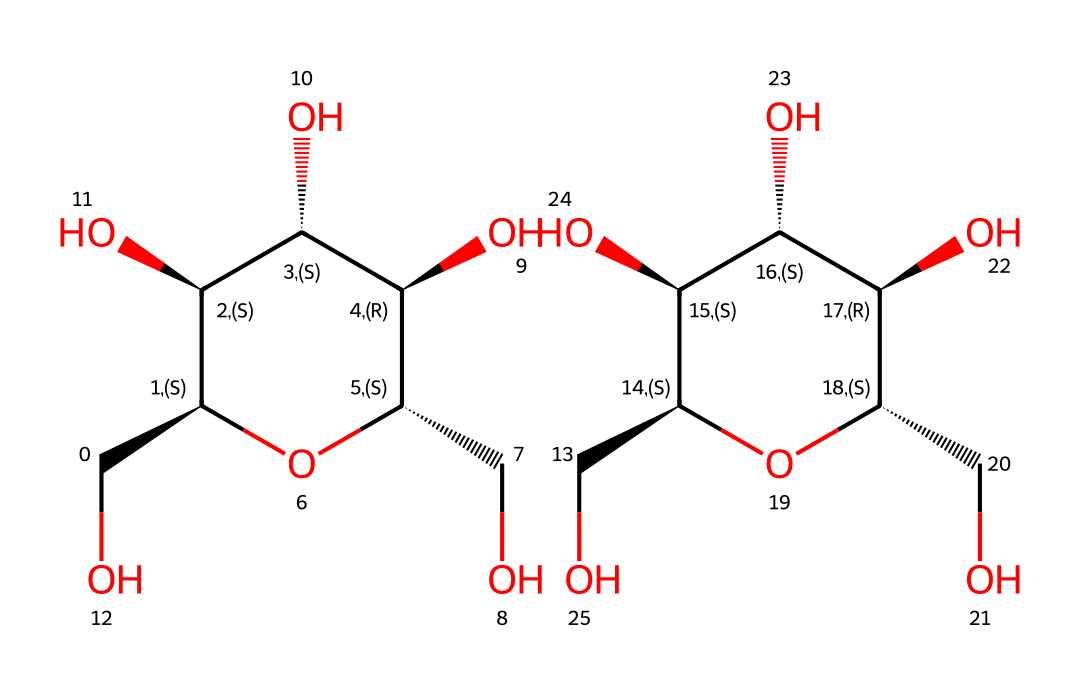What is the molecular formula of this starch molecule? The SMILES representation describes a chemical structure of starch. By analyzing the atoms represented in the structure, we find that the molecular formula is a combination of carbon (C), hydrogen (H), and oxygen (O). Counting the atoms from the two parts of the structure, we deduce the molecular formula as C12H22O11.
Answer: C12H22O11 How many rings are present in this chemical structure? The SMILES notation indicates that there are two cyclic structures (rings) present. Each cycle is formed by the notation that includes the sequence of atoms and the '@' symbols signify chirality in these rings. Hence, there are two ring structures in total.
Answer: 2 What functional groups are evident in this carbohydrate? Observing the structure closely, we see multiple hydroxyl (OH) groups attached to the carbon skeleton, which are typical for carbohydrates. There are no other functional groups present like aldehydes or ketones in this structure. Thus, the functional group is primarily hydroxyl.
Answer: hydroxyl What property does the presence of multiple hydroxyl groups suggest? The presence of multiple hydroxyl groups indicates that this carbohydrate exhibits strong hydrogen bonding capabilities. This property is significant as it contributes to dissolving in water and impacts physical properties relevant to its use in textiles and paper industries.
Answer: hydrophilicity Which type of carbohydrate is represented by this structure? The structure displayed represents a polysaccharide because it consists of multiple monosaccharide units linked together through glycosidic bonds, evident from the repetitiveness seen in the structure. Starch specifically is a storage polysaccharide.
Answer: polysaccharide 